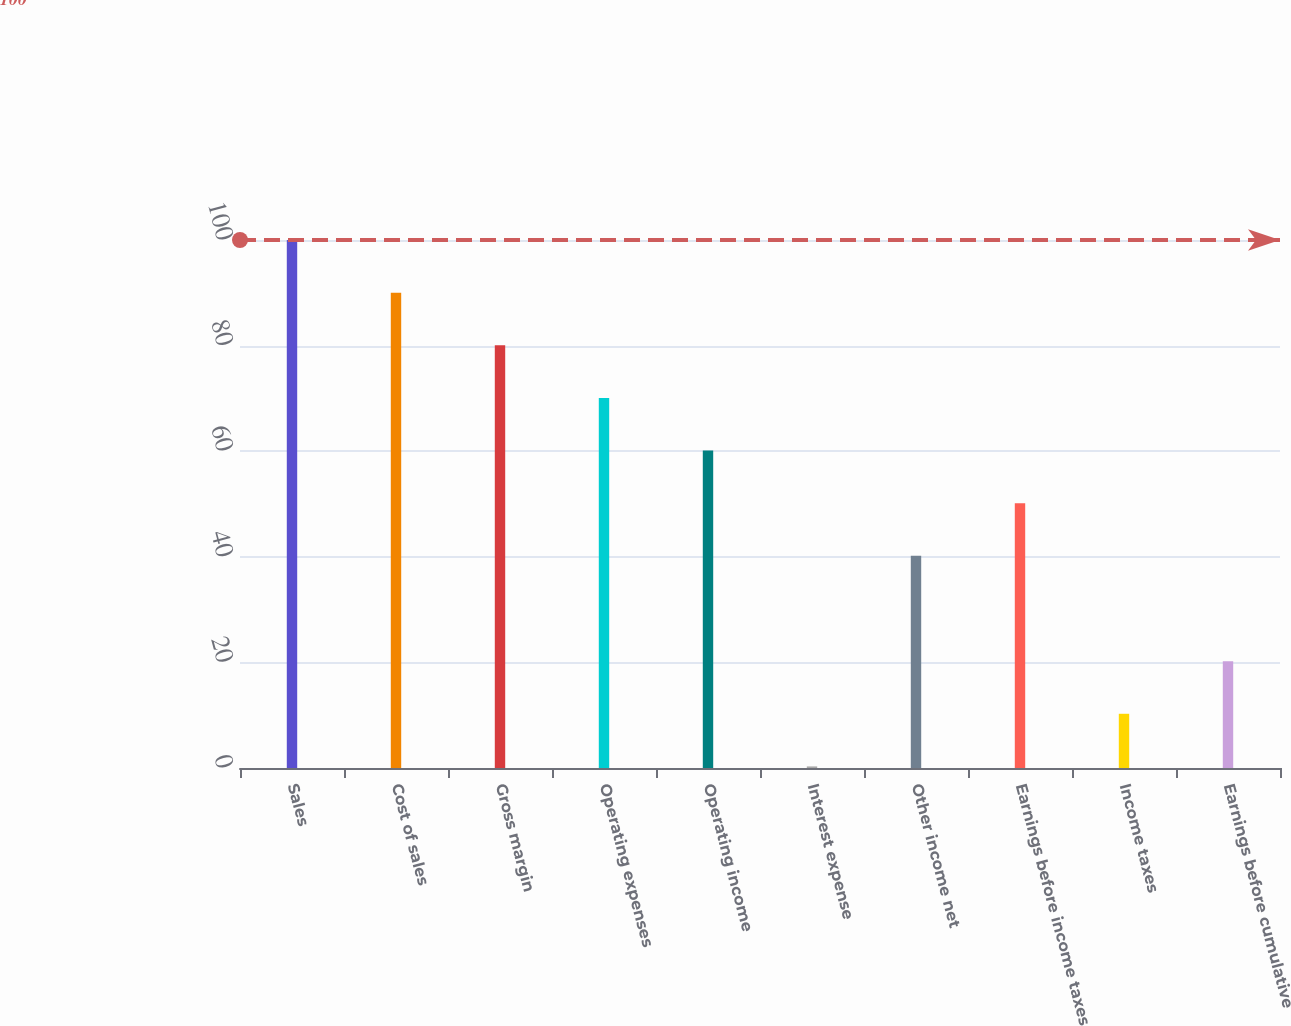Convert chart. <chart><loc_0><loc_0><loc_500><loc_500><bar_chart><fcel>Sales<fcel>Cost of sales<fcel>Gross margin<fcel>Operating expenses<fcel>Operating income<fcel>Interest expense<fcel>Other income net<fcel>Earnings before income taxes<fcel>Income taxes<fcel>Earnings before cumulative<nl><fcel>100<fcel>90.03<fcel>80.06<fcel>70.09<fcel>60.12<fcel>0.3<fcel>40.18<fcel>50.15<fcel>10.27<fcel>20.24<nl></chart> 